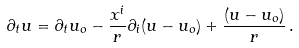<formula> <loc_0><loc_0><loc_500><loc_500>\partial _ { t } u = \partial _ { t } u _ { o } - \frac { x ^ { i } } { r } \partial _ { i } ( u - u _ { o } ) + \frac { ( u - u _ { o } ) } { r } \, .</formula> 